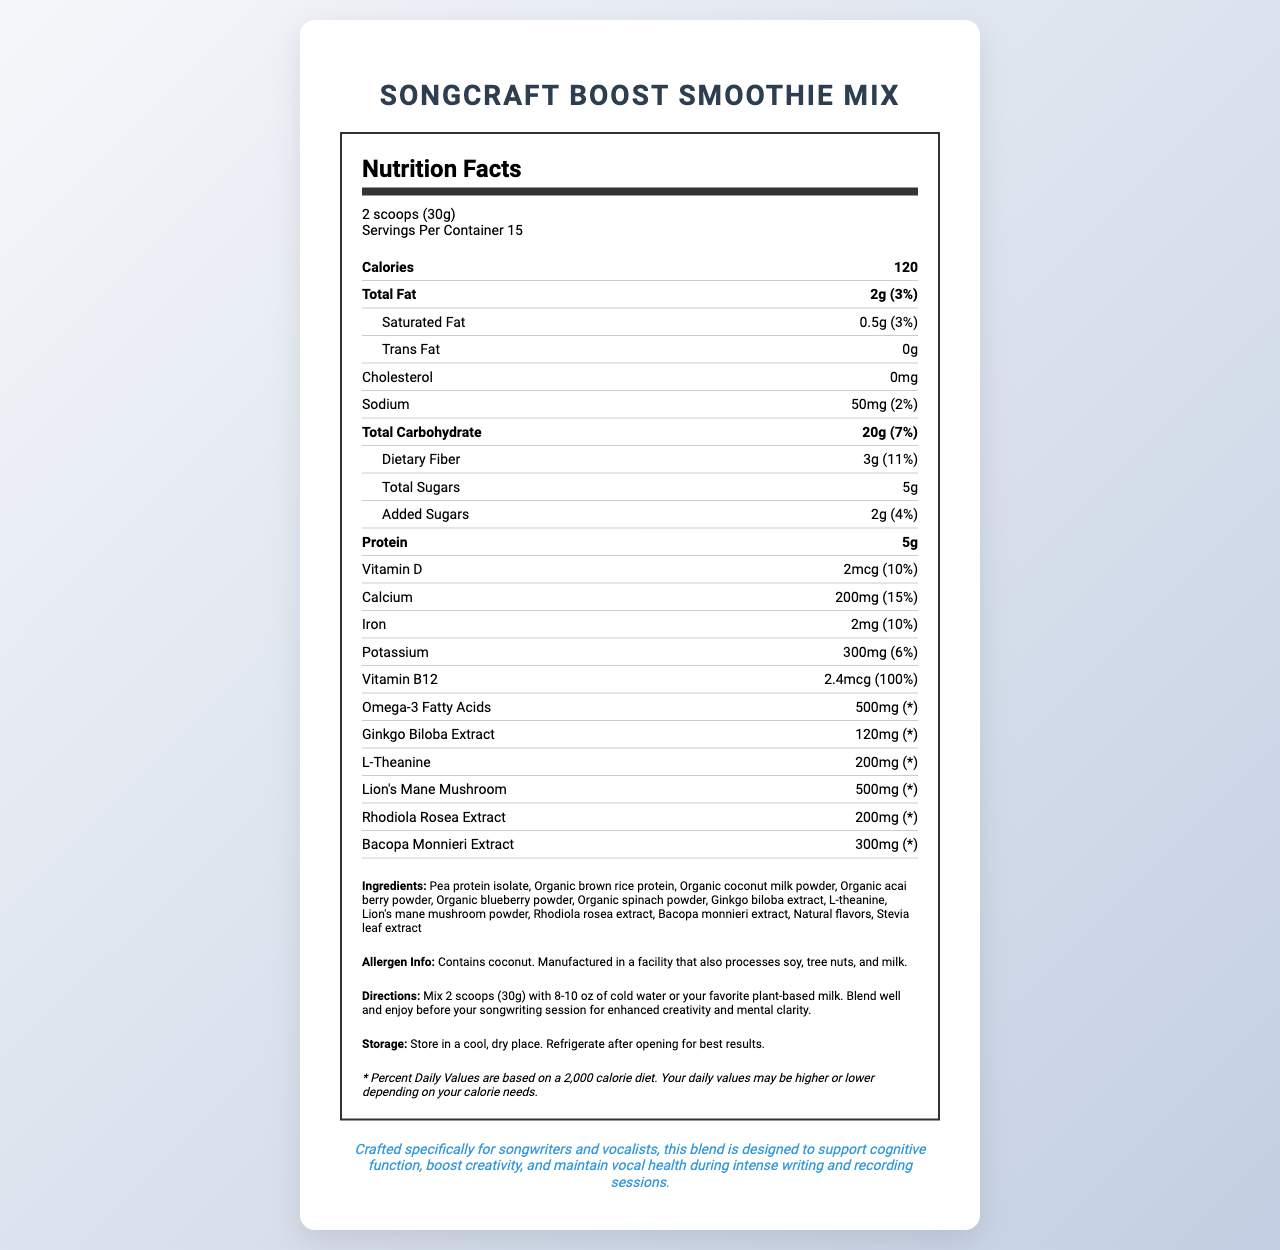what is the serving size of the SongCraft Boost Smoothie Mix? The serving size information is listed at the top of the nutrition facts section as "2 scoops (30g)".
Answer: 2 scoops (30g) how many calories are in one serving? The calorie content per serving is highlighted in the nutrition facts section next to the "Calories" label.
Answer: 120 what is the percentage of daily value for Vitamin B12 in one serving? The daily value percentage for Vitamin B12 is noted in the nutrition facts under the Vitamin B12 content as "2.4mcg (100%)".
Answer: 100% how much dietary fiber is in one serving? The amount of dietary fiber per serving is specified in the nutrition facts label under "Dietary Fiber" as "3g (11%)".
Answer: 3g how many servings are there in one container? The information about servings per container is indicated at the top of the nutrition facts label as "Servings Per Container 15".
Answer: 15 what are the ingredients in the SongCraft Boost Smoothie Mix? The ingredients list is provided in the document under the "Ingredients" section.
Answer: Pea protein isolate, Organic brown rice protein, Organic coconut milk powder, Organic acai berry powder, Organic blueberry powder, Organic spinach powder, Ginkgo biloba extract, L-theanine, Lion's mane mushroom powder, Rhodiola rosea extract, Bacopa monnieri extract, Natural flavors, Stevia leaf extract how much protein does one serving contain? The protein amount per serving is listed in the nutrition facts as "Protein 5g".
Answer: 5g Does the SongCraft Boost Smoothie Mix contain any dairy products? The allergen information notes that the product contains coconut and is manufactured in a facility that processes soy, tree nuts, and milk, but does not specifically list dairy as an ingredient.
Answer: No Should the SongCraft Boost Smoothie Mix be refrigerated after opening? The storage instructions state: "Refrigerate after opening for best results."
Answer: Yes what is the main target audience of this smoothie mix? The musician note at the end of the document specifies that the product is crafted for songwriters and vocalists to support cognitive function and boost creativity.
Answer: Songwriters and vocalists which of the following ingredients is not used in the SongCraft Boost Smoothie Mix? A. Organic spinach powder B. L-theanine C. Organic chia seeds D. Rhodiola rosea extract Organic chia seeds are not listed among the ingredients in the document.
Answer: C which nutrient has the highest daily value percentage per serving? I. Calcium II. Vitamin B12 III. Dietary Fiber Vitamin B12 has the highest daily value percentage per serving, being 100%.
Answer: II Is the total fat content in one serving higher than the protein content? The total fat content in one serving is 2g, which is lower than the protein content of 5g.
Answer: No Summarize the main idea of the SongCraft Boost Smoothie Mix nutrition label. The summary captures the purpose, nutritional content, target audience, and key pieces of information that the nutrition label provides, offering a comprehensive overview of the product.
Answer: The SongCraft Boost Smoothie Mix is a vitamin-rich nutritional supplement designed to enhance cognitive function and creativity, specifically targeting songwriters and vocalists. It contains 120 calories per serving with beneficial ingredients such as pea protein, organic powders, and extracts like Ginkgo Biloba and Bacopa Monnieri. The blend provides essential nutrients such as protein, dietary fiber, Vitamin B12, and Omega-3 fatty acids. Directions and allergen information are included, along with the emphasis to refrigerate after opening. How long will it take for the smoothie mix to show effects on creativity enhancement? The document does not provide any information about the time frame in which the smoothie mix might show effects on creativity enhancement.
Answer: Cannot be determined 